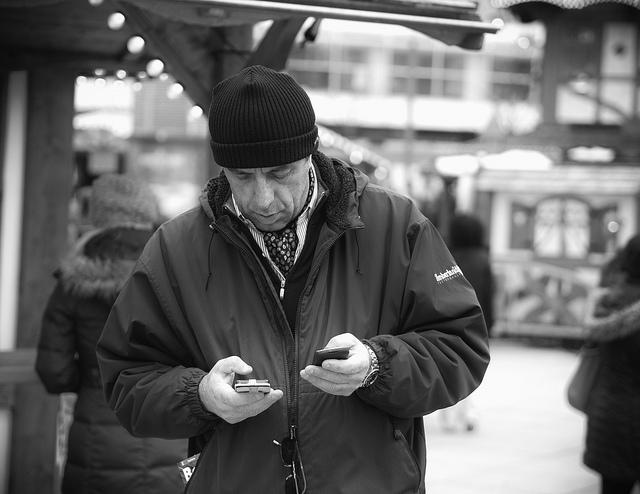What is the man looking at?
Concise answer only. Phone. Is he wearing a hat?
Write a very short answer. Yes. What is attached to the mans zippers?
Give a very brief answer. Sunglasses. 